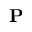Convert formula to latex. <formula><loc_0><loc_0><loc_500><loc_500>P</formula> 